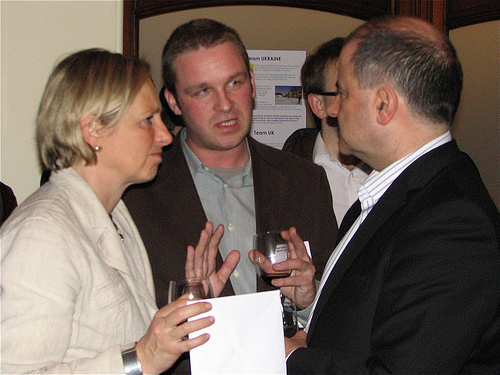<image>
Can you confirm if the man is to the left of the man? Yes. From this viewpoint, the man is positioned to the left side relative to the man. Is there a man to the left of the woman? No. The man is not to the left of the woman. From this viewpoint, they have a different horizontal relationship. 